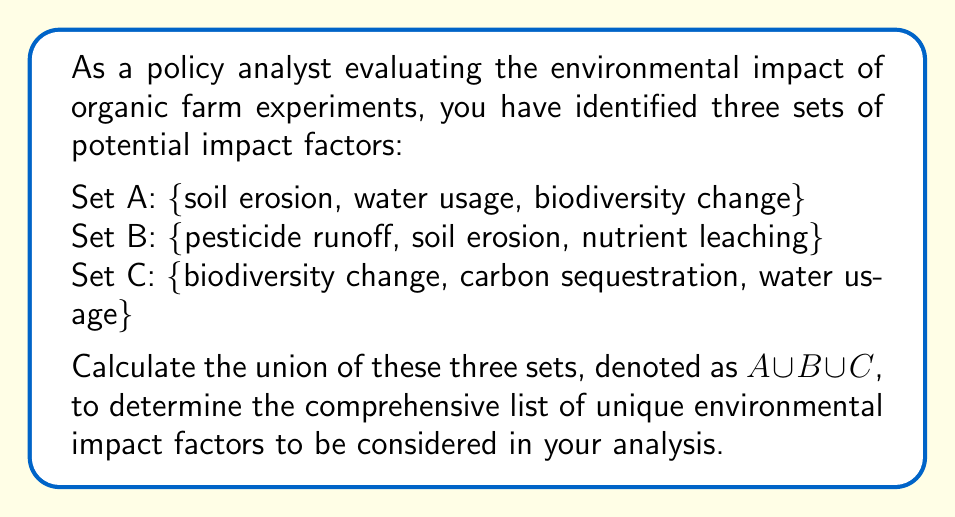Solve this math problem. To find the union of sets A, B, and C, we need to combine all unique elements from all three sets. Let's approach this step-by-step:

1. First, let's list out all elements from all sets:
   A: soil erosion, water usage, biodiversity change
   B: pesticide runoff, soil erosion, nutrient leaching
   C: biodiversity change, carbon sequestration, water usage

2. Now, we'll create a new set that includes all unique elements:

   $A \cup B \cup C = \{$ soil erosion, water usage, biodiversity change, pesticide runoff, nutrient leaching, carbon sequestration $\}$

3. Note that we only list each element once, even if it appears in multiple original sets:
   - "soil erosion" appears in both A and B, but we only list it once.
   - "water usage" appears in both A and C, but we only list it once.
   - "biodiversity change" appears in both A and C, but we only list it once.

4. The resulting set has 6 unique elements.

5. We can represent this union mathematically as:

   $$A \cup B \cup C = \{x \mid x \in A \text{ or } x \in B \text{ or } x \in C\}$$

   This reads as "the set of all elements x such that x is in A or B or C."
Answer: $A \cup B \cup C = \{$ soil erosion, water usage, biodiversity change, pesticide runoff, nutrient leaching, carbon sequestration $\}$ 